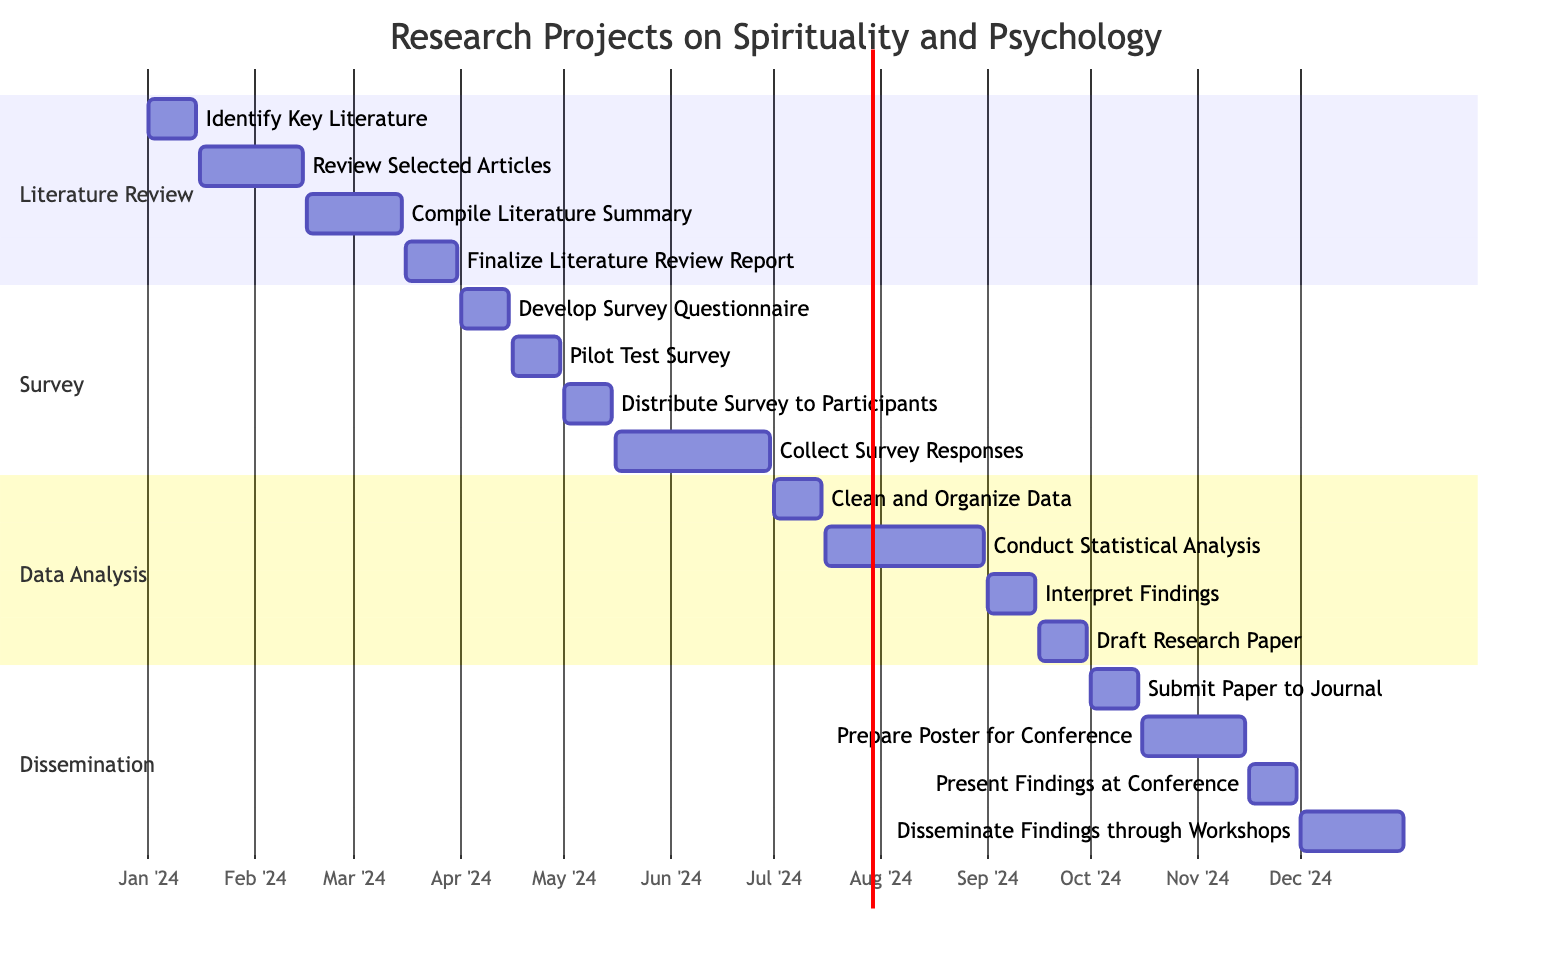What is the duration of the Literature Review phase? The Literature Review phase spans from January 1, 2024, to March 31, 2024, which totals 3 months.
Answer: 3 months How many tasks are there in the Data Analysis section? The Data Analysis section contains 4 tasks: Clean and Organize Data, Conduct Statistical Analysis, Interpret Findings, and Draft Research Paper.
Answer: 4 tasks Which task concludes the Survey phase? The final task in the Survey phase is Collect Survey Responses, scheduled from May 16 to June 30, 2024.
Answer: Collect Survey Responses What is the starting date of the task that involves presenting findings at a conference? The task Present Findings at Conference starts on November 16, 2024.
Answer: November 16, 2024 Which task has the longest duration in the Dissemination section? The task Prepare Poster for Conference lasts from October 16 to November 15, 2024, making it 31 days long.
Answer: Prepare Poster for Conference What is the end date for the Compile Literature Summary task? The Compile Literature Summary task concludes on March 15, 2024.
Answer: March 15, 2024 What is the relationship between the Review Selected Articles and the Compile Literature Summary tasks? Review Selected Articles must be completed by February 15, 2024, before starting Compile Literature Summary, which begins on February 16, 2024, thus indicating a dependency.
Answer: A dependency How long does data cleaning take? The Clean and Organize Data task lasts from July 1 to July 15, 2024, which is 15 days.
Answer: 15 days What are the total months for the entire research project timeline? The research project spans from January 1, 2024, to December 31, 2024, totaling 12 months.
Answer: 12 months 